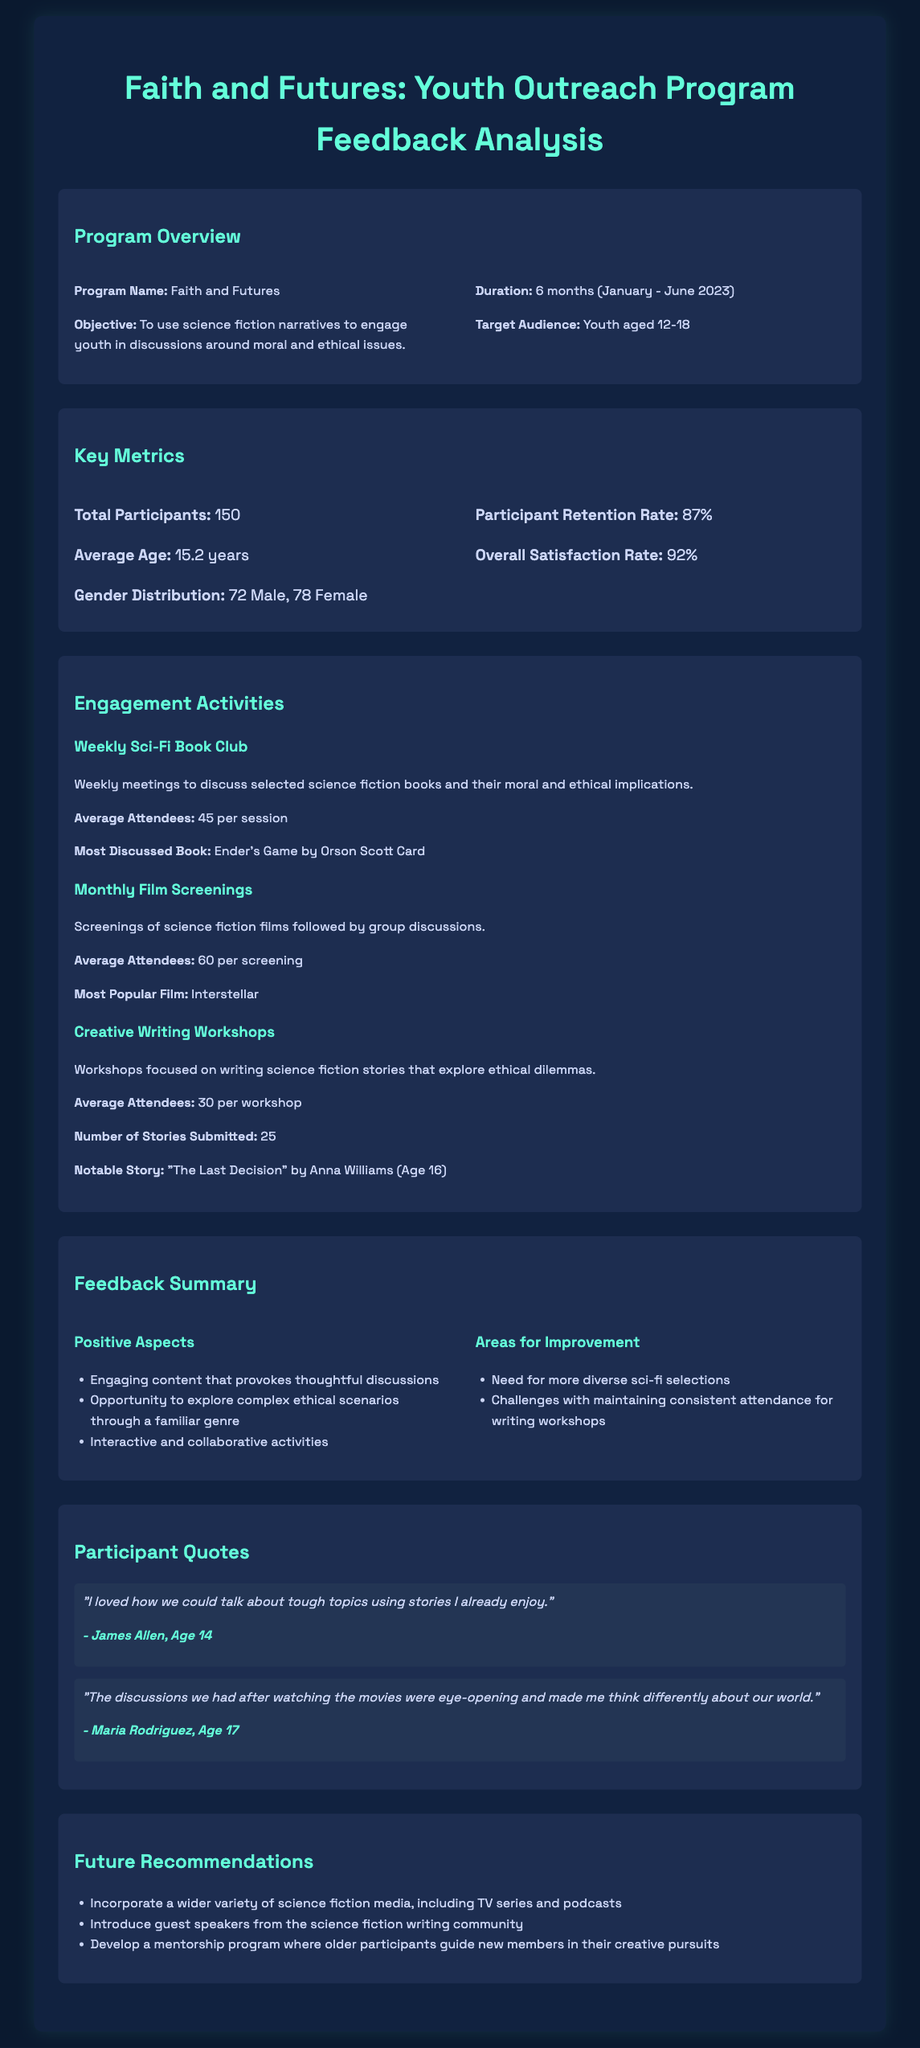what is the program name? The program name is stated under the Program Overview section as "Faith and Futures."
Answer: Faith and Futures how many participants were there? The document indicates that there were 150 participants enrolled in the program.
Answer: 150 what is the average age of participants? The average age is provided in the Key Metrics section and is stated as 15.2 years.
Answer: 15.2 years what percentage represents the participant retention rate? The retention rate is explicitly mentioned in the Key Metrics section as 87%.
Answer: 87% which book was most discussed in the Sci-Fi Book Club? The most discussed book in the activity description is mentioned as "Ender's Game by Orson Scott Card."
Answer: Ender's Game by Orson Scott Card what was a common positive aspect of the program? The document lists "engaging content that provokes thoughtful discussions" as a positive aspect from the Feedback Summary.
Answer: engaging content that provokes thoughtful discussions what did participants suggest as an area for improvement? One area for improvement mentioned is "need for more diverse sci-fi selections."
Answer: need for more diverse sci-fi selections who submitted a notable story and what was its title? The notable story was written by Anna Williams, and the title is "The Last Decision."
Answer: "The Last Decision" by Anna Williams what type of media does the future recommendations suggest incorporating? The future recommendations suggest incorporating "a wider variety of science fiction media, including TV series and podcasts."
Answer: a wider variety of science fiction media, including TV series and podcasts 